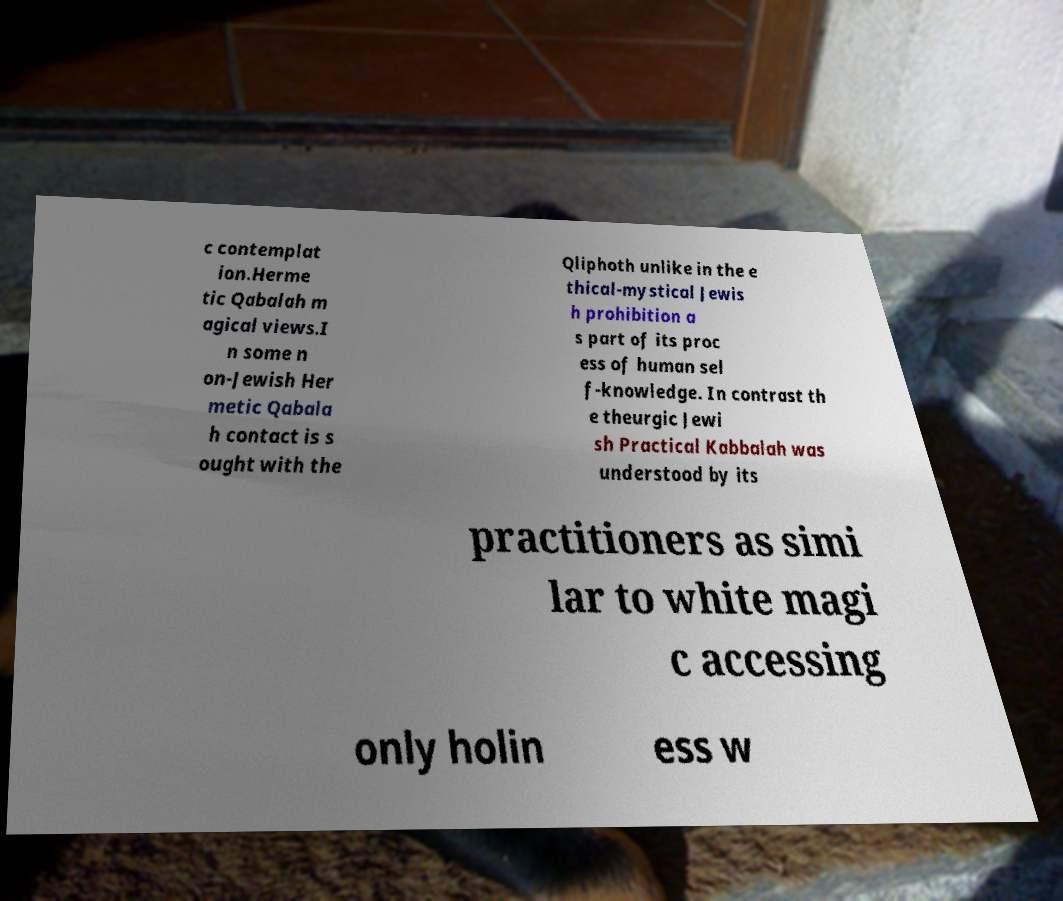What messages or text are displayed in this image? I need them in a readable, typed format. c contemplat ion.Herme tic Qabalah m agical views.I n some n on-Jewish Her metic Qabala h contact is s ought with the Qliphoth unlike in the e thical-mystical Jewis h prohibition a s part of its proc ess of human sel f-knowledge. In contrast th e theurgic Jewi sh Practical Kabbalah was understood by its practitioners as simi lar to white magi c accessing only holin ess w 